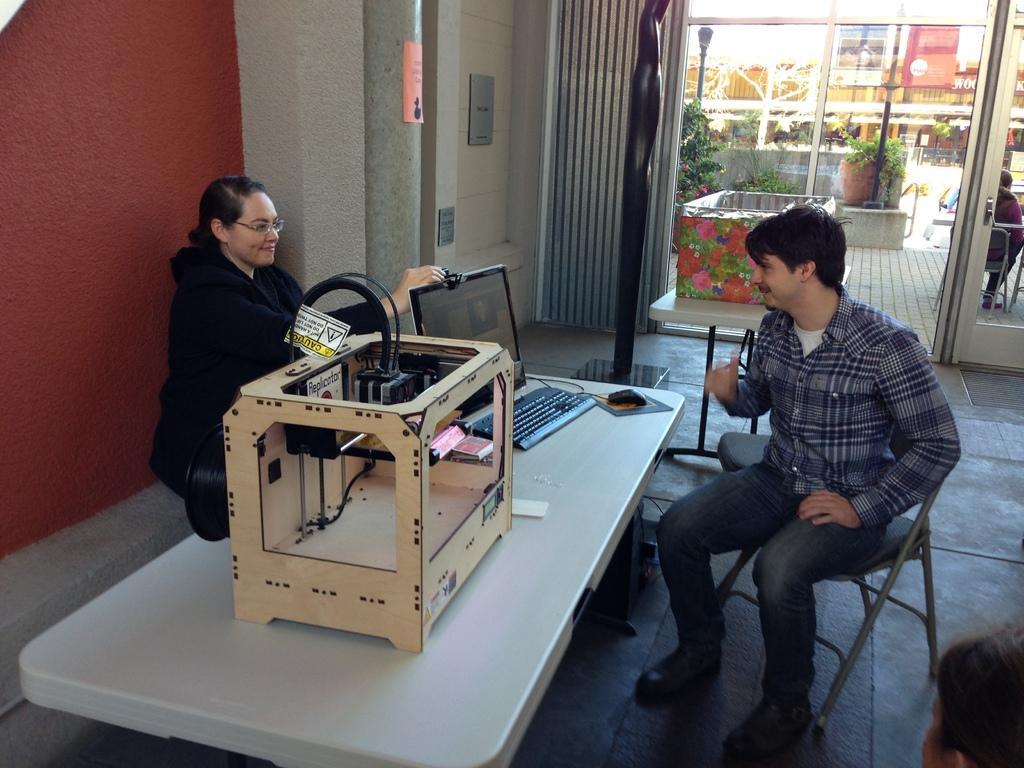Describe this image in one or two sentences. In the image we can see there are people who are sitting on chair and on table there is monitor, keyboard, mouse and a wooden box like a machine and there is curtain on window and the wall is in red colour. On the other side there are plants. 